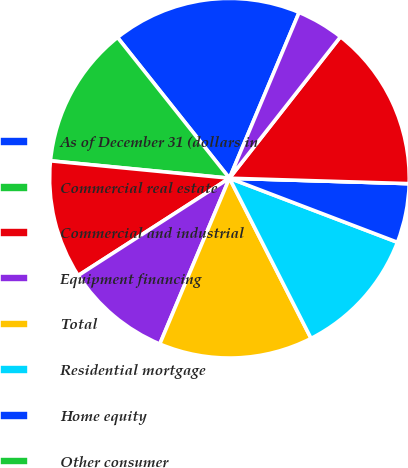Convert chart to OTSL. <chart><loc_0><loc_0><loc_500><loc_500><pie_chart><fcel>As of December 31 (dollars in<fcel>Commercial real estate<fcel>Commercial and industrial<fcel>Equipment financing<fcel>Total<fcel>Residential mortgage<fcel>Home equity<fcel>Other consumer<fcel>Total originated<fcel>Residential<nl><fcel>17.02%<fcel>12.77%<fcel>10.64%<fcel>9.57%<fcel>13.83%<fcel>11.7%<fcel>5.32%<fcel>0.0%<fcel>14.89%<fcel>4.26%<nl></chart> 